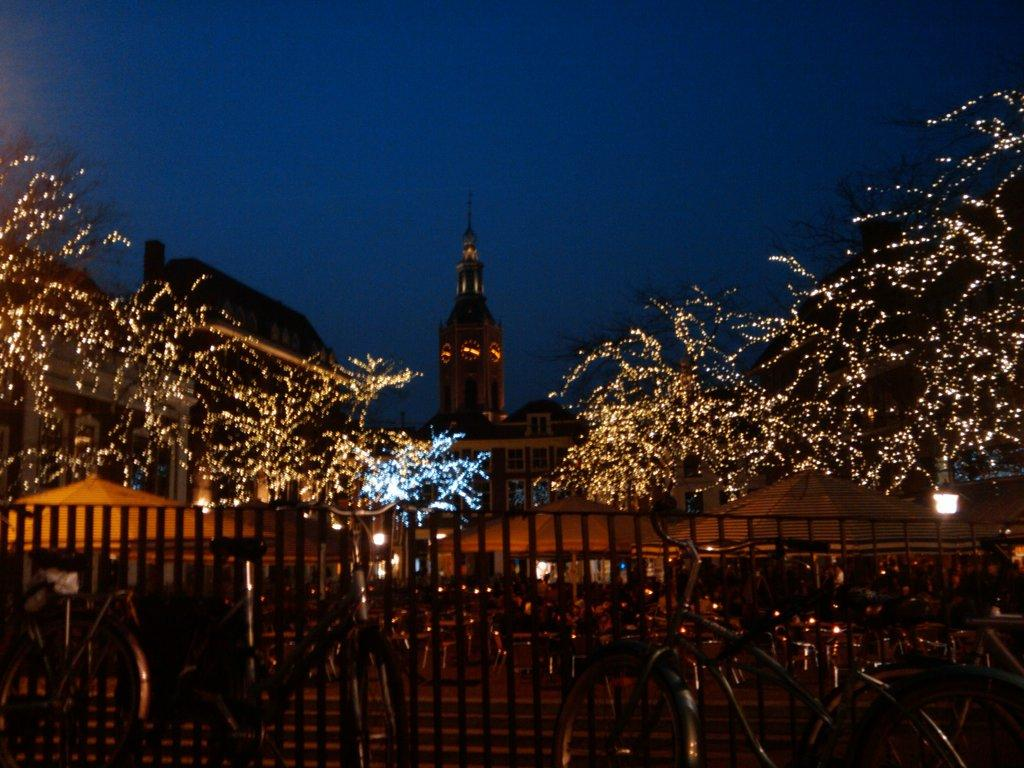What is decorating the trees in the image? The trees are decorated with string lights in the image. What type of structure can be seen in the image? There is a fence in the image. What mode of transportation is present in the image? There are bicycles in the image. What type of structures are visible in the image? There are buildings and a tower in the image. What can be seen in the background of the image? The sky is visible in the background of the image. What type of brass instrument is being played in the image? There is no brass instrument present in the image. What noise can be heard coming from the tower in the image? The image is silent, and no noise can be heard. 